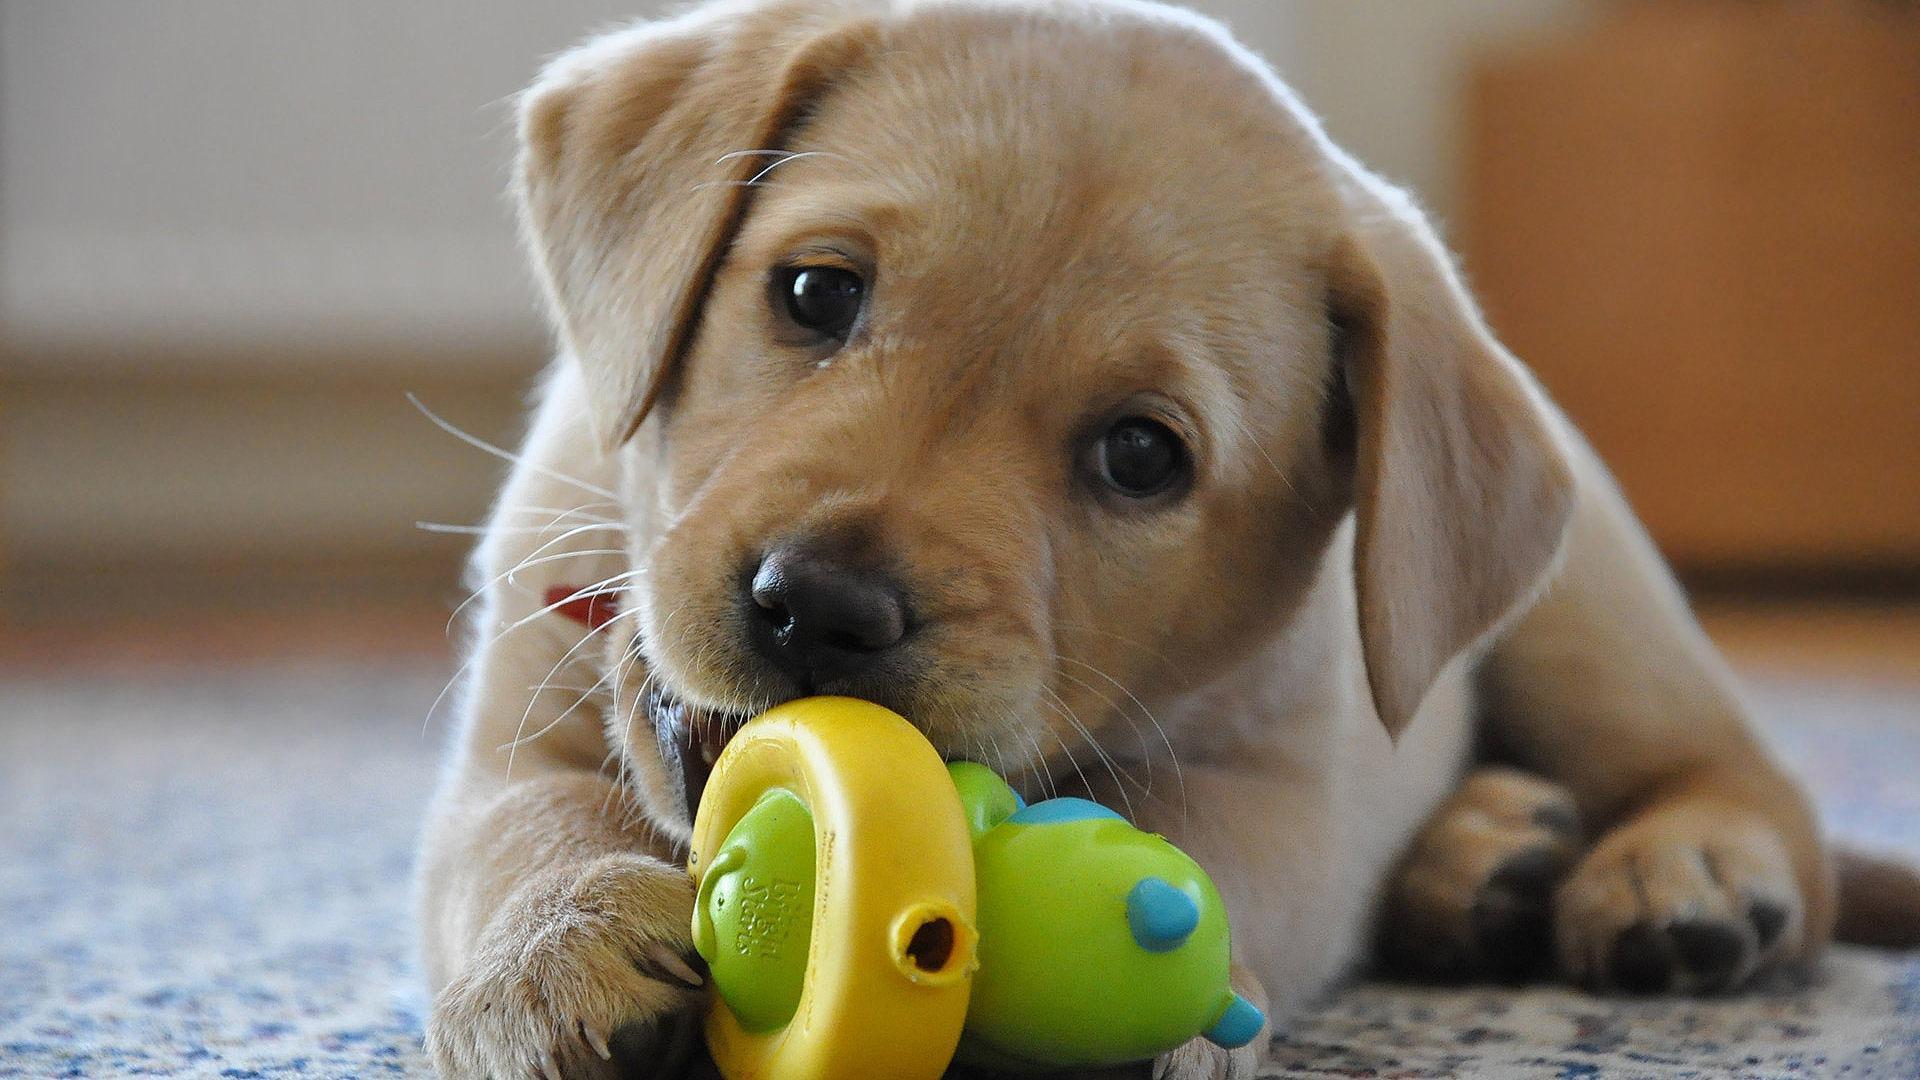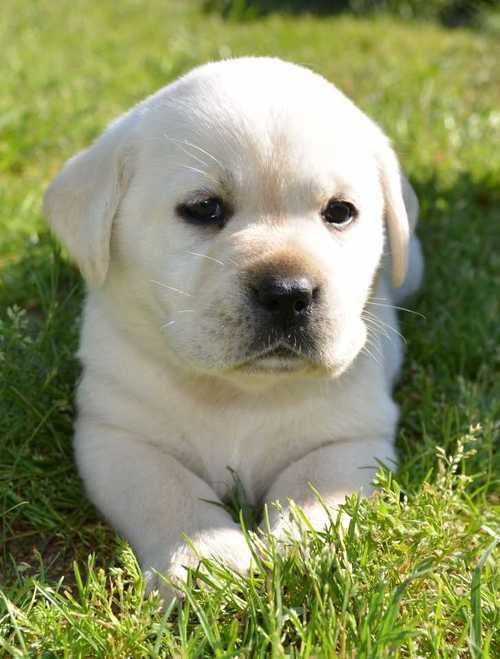The first image is the image on the left, the second image is the image on the right. Examine the images to the left and right. Is the description "There are at least three dogs in the right image." accurate? Answer yes or no. No. The first image is the image on the left, the second image is the image on the right. Examine the images to the left and right. Is the description "Atleast 4 dogs total" accurate? Answer yes or no. No. 